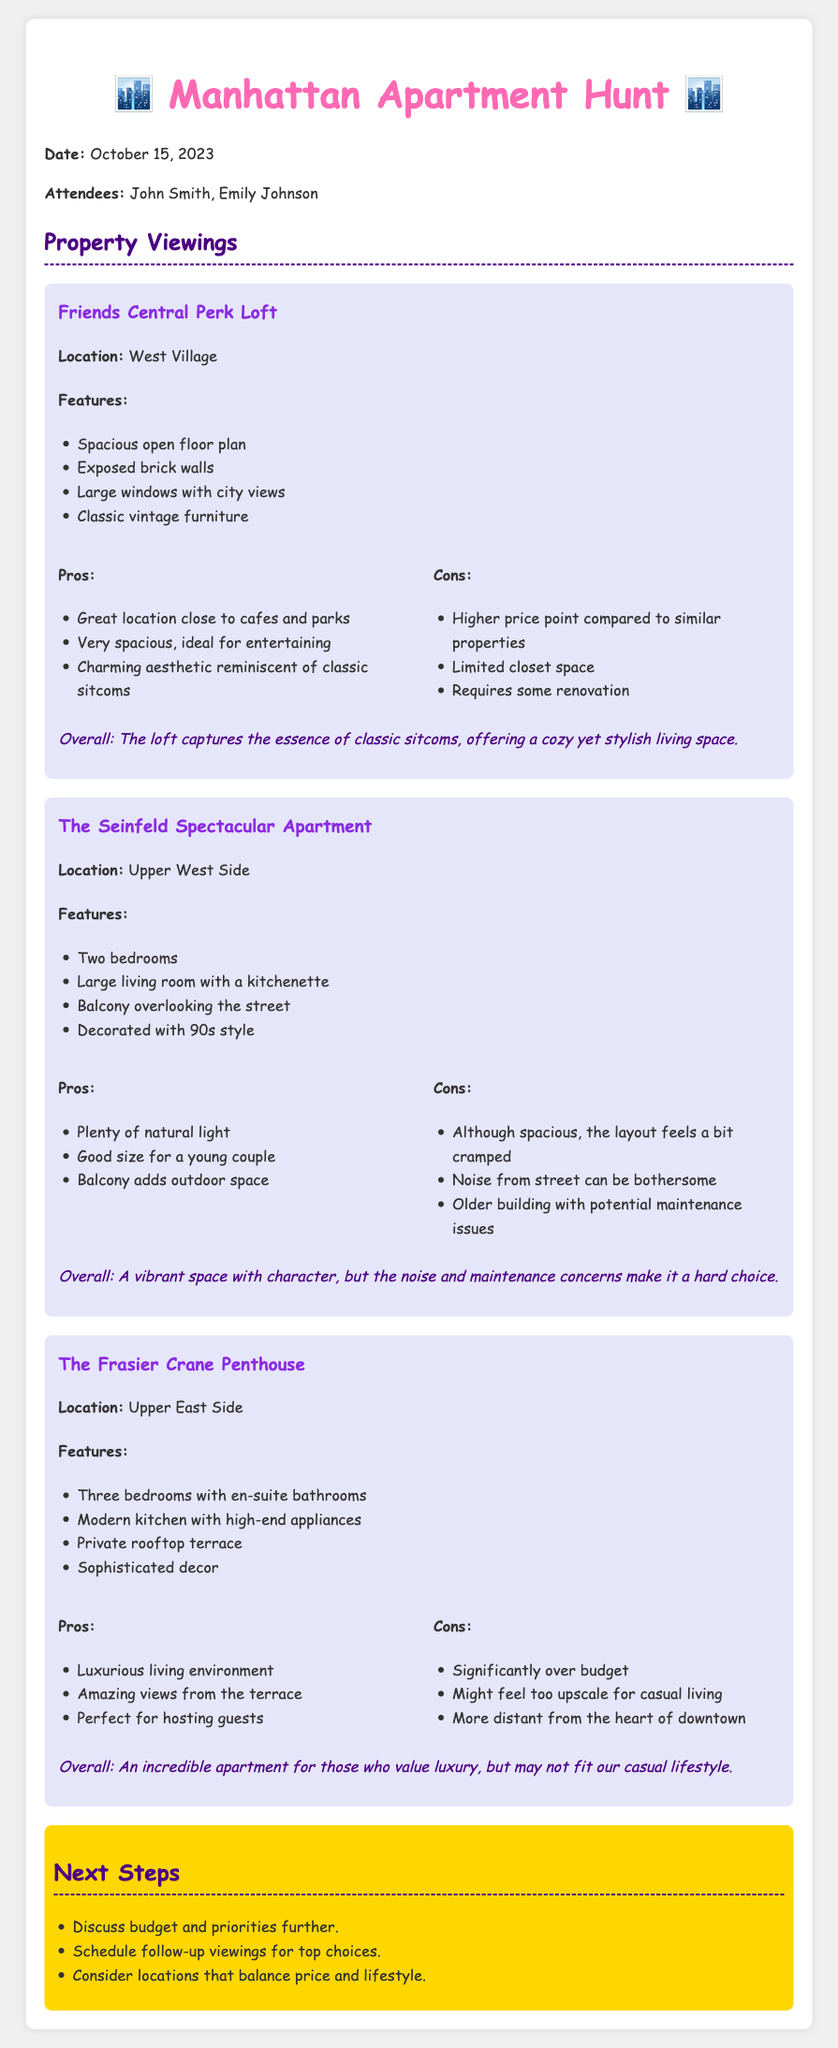What is the date of the meeting? The date is stated at the beginning of the document.
Answer: October 15, 2023 Who attended the meeting? The attendees are listed in the introduction section of the document.
Answer: John Smith, Emily Johnson What is a feature of the Friends Central Perk Loft? The features are detailed under each property section; one of the loft's features is listed.
Answer: Spacious open floor plan What is a con of The Seinfeld Spectacular Apartment? The cons are listed in the properties; one con of this apartment is mentioned.
Answer: Noise from street can be bothersome How many bedrooms does The Frasier Crane Penthouse have? The number of bedrooms is indicated in the features section of the penthouse.
Answer: Three bedrooms What is a pro of The Frasier Crane Penthouse? The pros are outlined in the document; one pro for this apartment is stated.
Answer: Luxurious living environment What is the location of the Friends Central Perk Loft? The location is specified in each property section.
Answer: West Village What suggestion is mentioned in the next steps? The next steps are listed; one suggestion is provided.
Answer: Discuss budget and priorities further What style is The Seinfeld Spectacular Apartment decorated with? The style is described in the features section of the apartment.
Answer: 90s style What is the overall impression of the Friends Central Perk Loft? Overall impressions are provided at the end of each property section.
Answer: The loft captures the essence of classic sitcoms, offering a cozy yet stylish living space 